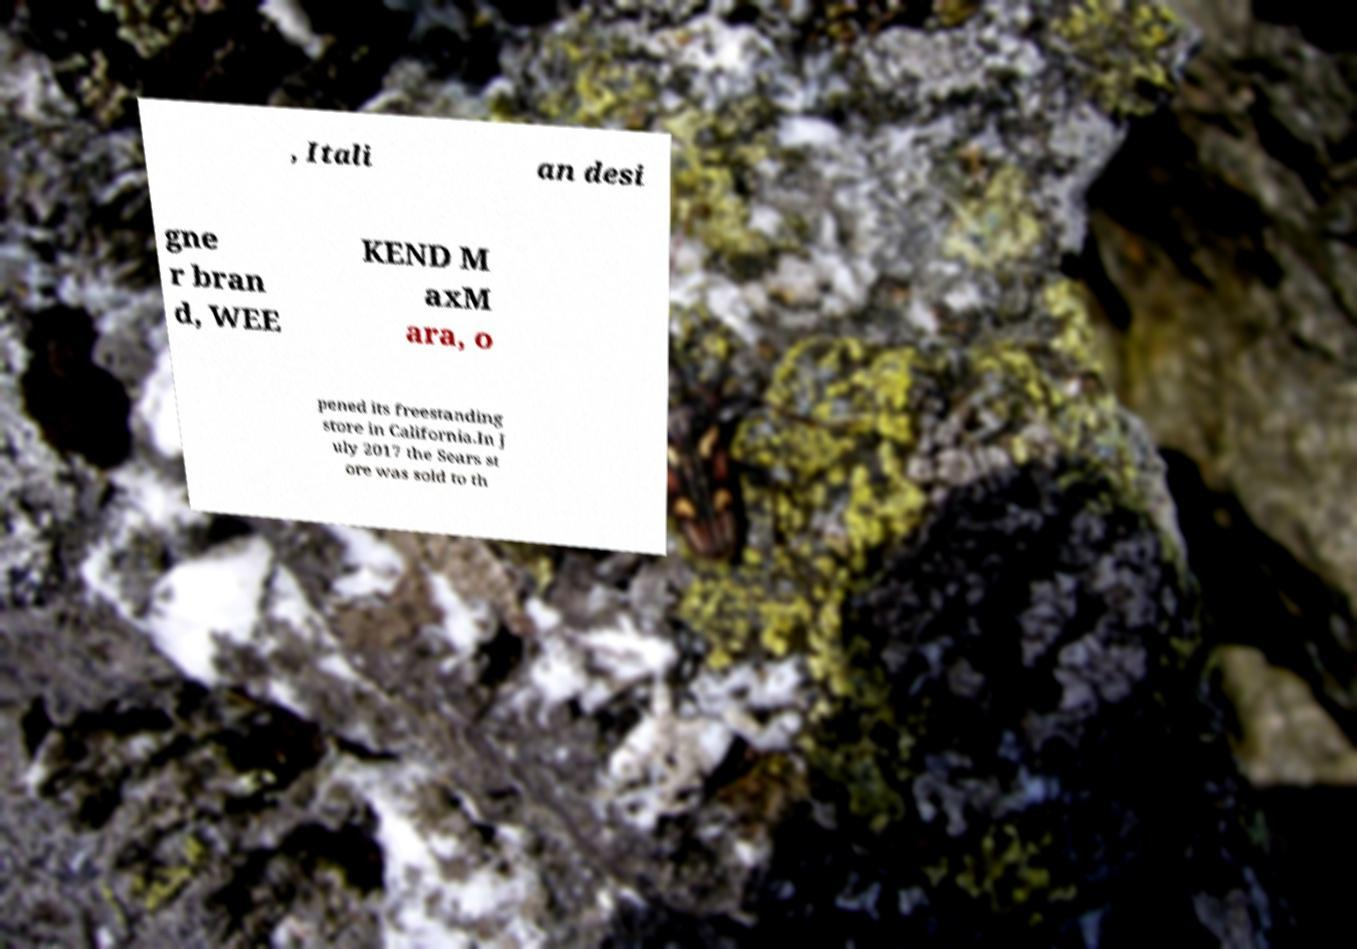Can you accurately transcribe the text from the provided image for me? , Itali an desi gne r bran d, WEE KEND M axM ara, o pened its freestanding store in California.In J uly 2017 the Sears st ore was sold to th 